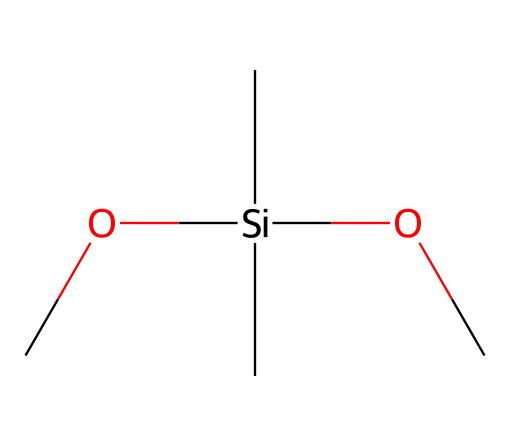What is the central atom in this chemical structure? In the provided SMILES, the central atom is silicon (Si), which can be identified as it is surrounded by multiple carbon and oxygen atoms, indicating it is the core of this organosilicon compound.
Answer: silicon How many carbon atoms are present in this structure? By analyzing the SMILES, we see there are four carbon (C) atoms attached to the silicon atom, as each "C" represents a separate carbon.
Answer: four What functional group is indicated by the "OC" part of the SMILES? The "OC" part of the SMILES indicates the presence of an alkoxy group (alkyl-oxygen), which consists of an oxygen atom bonded to a carbon chain, hinting at the compound's potential for water-repellent properties.
Answer: alkoxy How many total atoms are in this chemical? The chemical consists of one silicon atom, four carbon atoms, and two oxygen atoms, totaling seven atoms when combined. The calculation involves adding up all the identified atoms in the SMILES notation.
Answer: seven What type of bonding is primarily present in this compound? The compound largely features single covalent bonds (sigma bonds) between silicon and its connected carbon and oxygen atoms, as indicated by the absence of double or triple bond notations in the SMILES.
Answer: single covalent bonds What kind of compound does this silane represent in the context of military applications? This silane represents an organosilicon compound used for waterproofing military equipment, as indicated by its structure designed to repel water due to the presence of alkoxy groups.
Answer: waterproofing agent What is the potential application of the alkoxy groups in this structure? The alkoxy groups may provide hydrophobic properties, enhancing the water repellency of the compound, making it suitable for protecting military equipment from moisture damage.
Answer: hydrophobic properties 